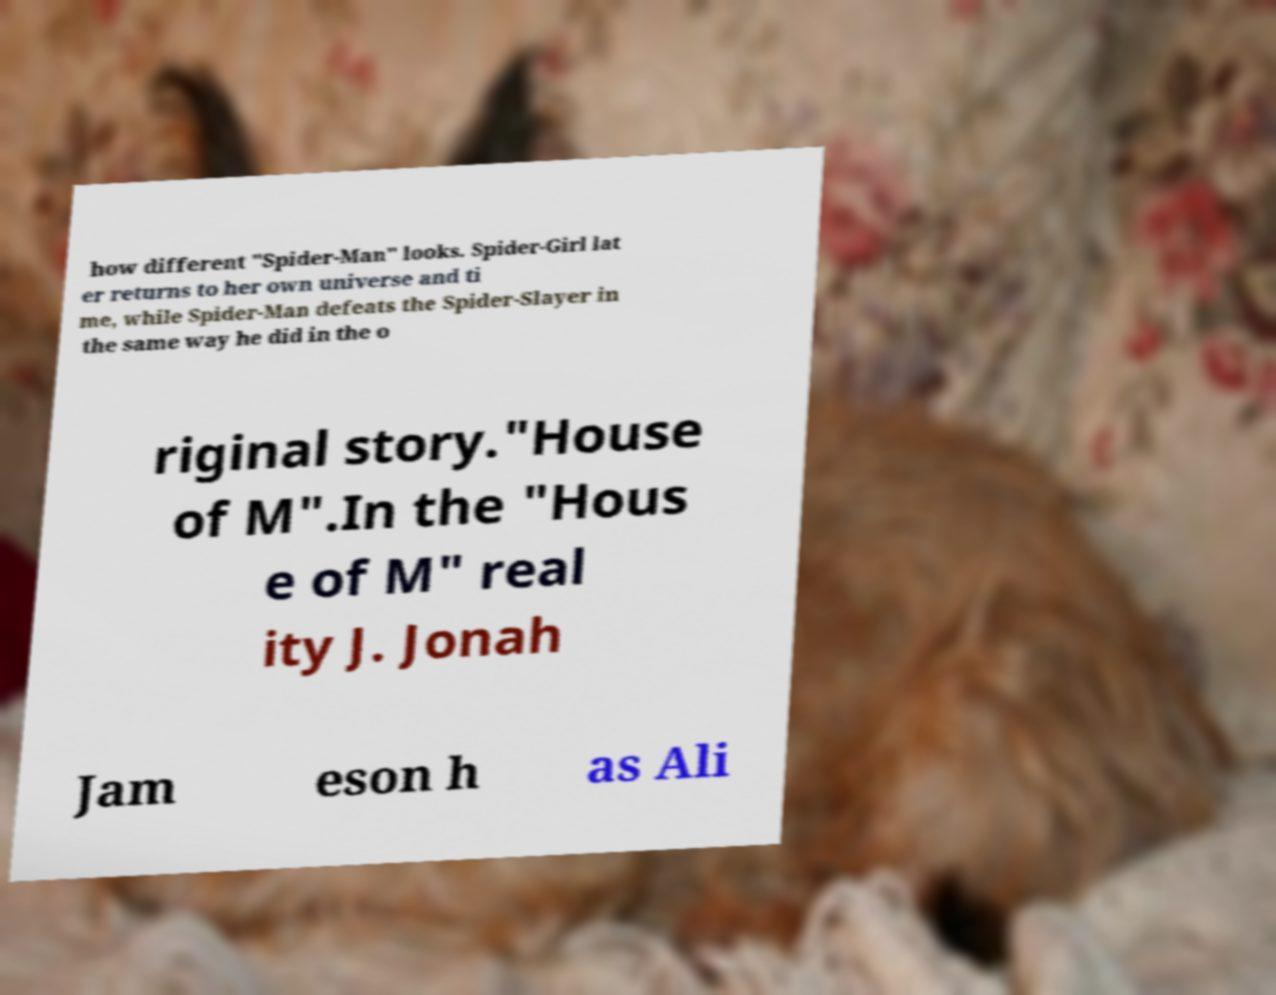For documentation purposes, I need the text within this image transcribed. Could you provide that? how different "Spider-Man" looks. Spider-Girl lat er returns to her own universe and ti me, while Spider-Man defeats the Spider-Slayer in the same way he did in the o riginal story."House of M".In the "Hous e of M" real ity J. Jonah Jam eson h as Ali 